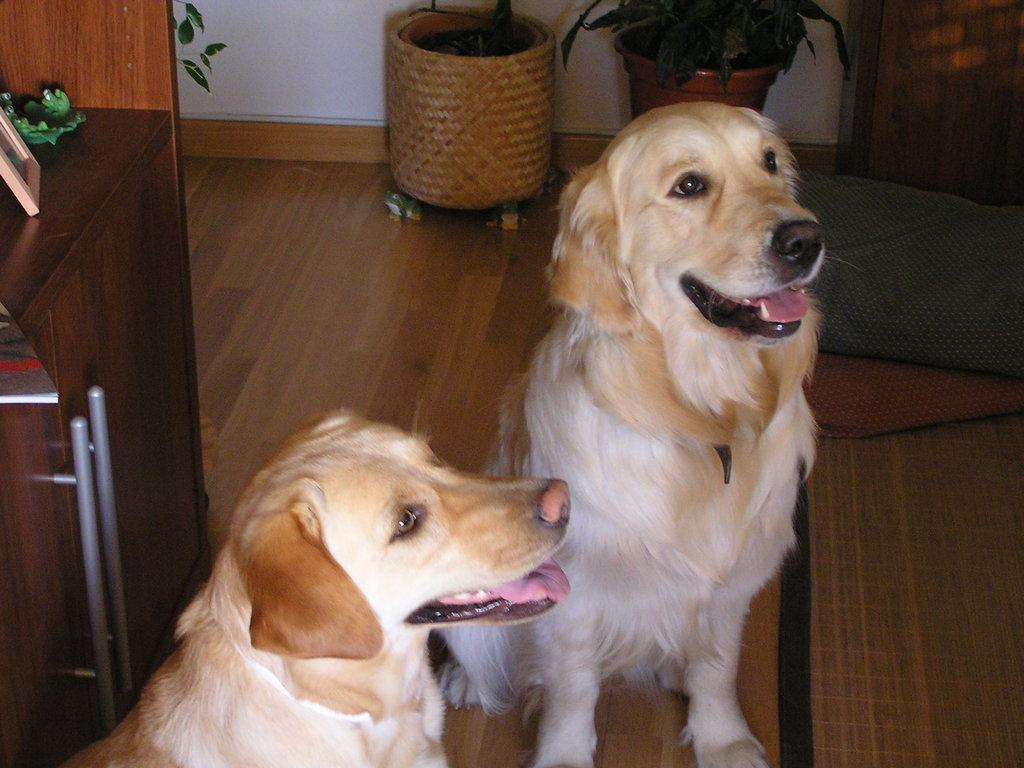Could you give a brief overview of what you see in this image? This picture is clicked inside the room. In front of the picture, we see two dogs. On the left side, we see a table on which book and a photo frame are placed. Beside that, we see a brown door. In the background, we see the plant pots and a white wall. On the right side, we see the carpets in grey and red color. Behind that, we see a brown door. At the bottom, we see the wooden floor. 